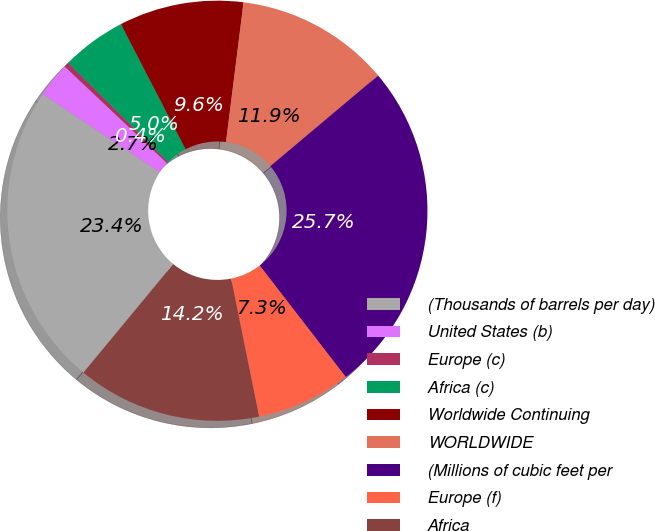Convert chart. <chart><loc_0><loc_0><loc_500><loc_500><pie_chart><fcel>(Thousands of barrels per day)<fcel>United States (b)<fcel>Europe (c)<fcel>Africa (c)<fcel>Worldwide Continuing<fcel>WORLDWIDE<fcel>(Millions of cubic feet per<fcel>Europe (f)<fcel>Africa<nl><fcel>23.37%<fcel>2.68%<fcel>0.38%<fcel>4.98%<fcel>9.58%<fcel>11.88%<fcel>25.67%<fcel>7.28%<fcel>14.18%<nl></chart> 